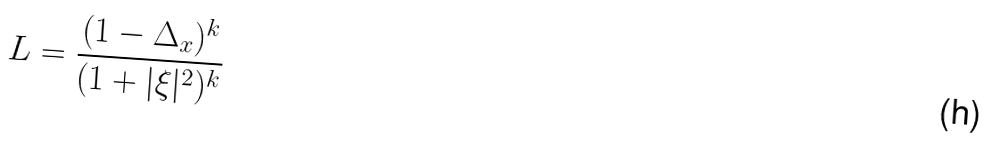Convert formula to latex. <formula><loc_0><loc_0><loc_500><loc_500>L = \frac { ( 1 - \Delta _ { x } ) ^ { k } } { ( 1 + | \xi | ^ { 2 } ) ^ { k } }</formula> 